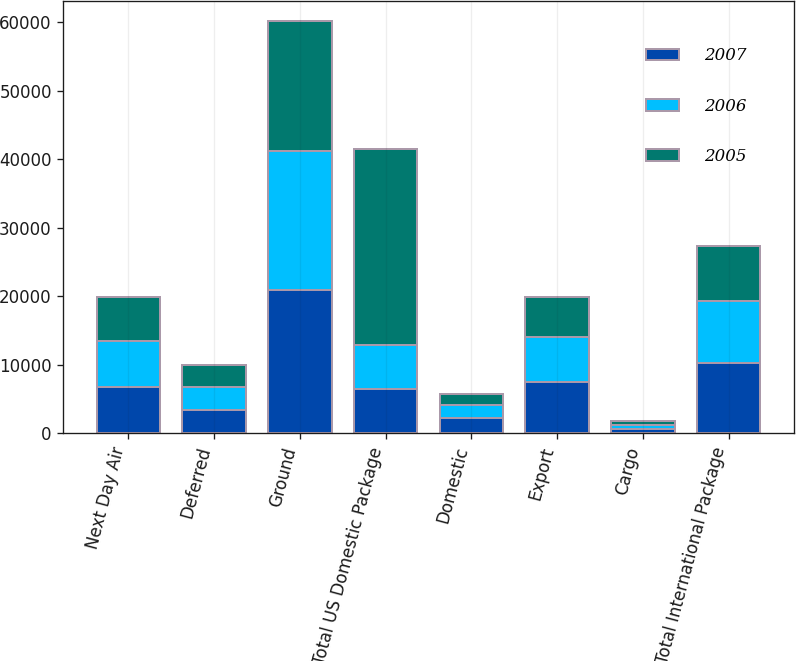<chart> <loc_0><loc_0><loc_500><loc_500><stacked_bar_chart><ecel><fcel>Next Day Air<fcel>Deferred<fcel>Ground<fcel>Total US Domestic Package<fcel>Domestic<fcel>Export<fcel>Cargo<fcel>Total International Package<nl><fcel>2007<fcel>6738<fcel>3359<fcel>20888<fcel>6467.5<fcel>2177<fcel>7488<fcel>616<fcel>10281<nl><fcel>2006<fcel>6778<fcel>3424<fcel>20254<fcel>6467.5<fcel>1950<fcel>6554<fcel>585<fcel>9089<nl><fcel>2005<fcel>6381<fcel>3258<fcel>18971<fcel>28610<fcel>1588<fcel>5856<fcel>533<fcel>7977<nl></chart> 